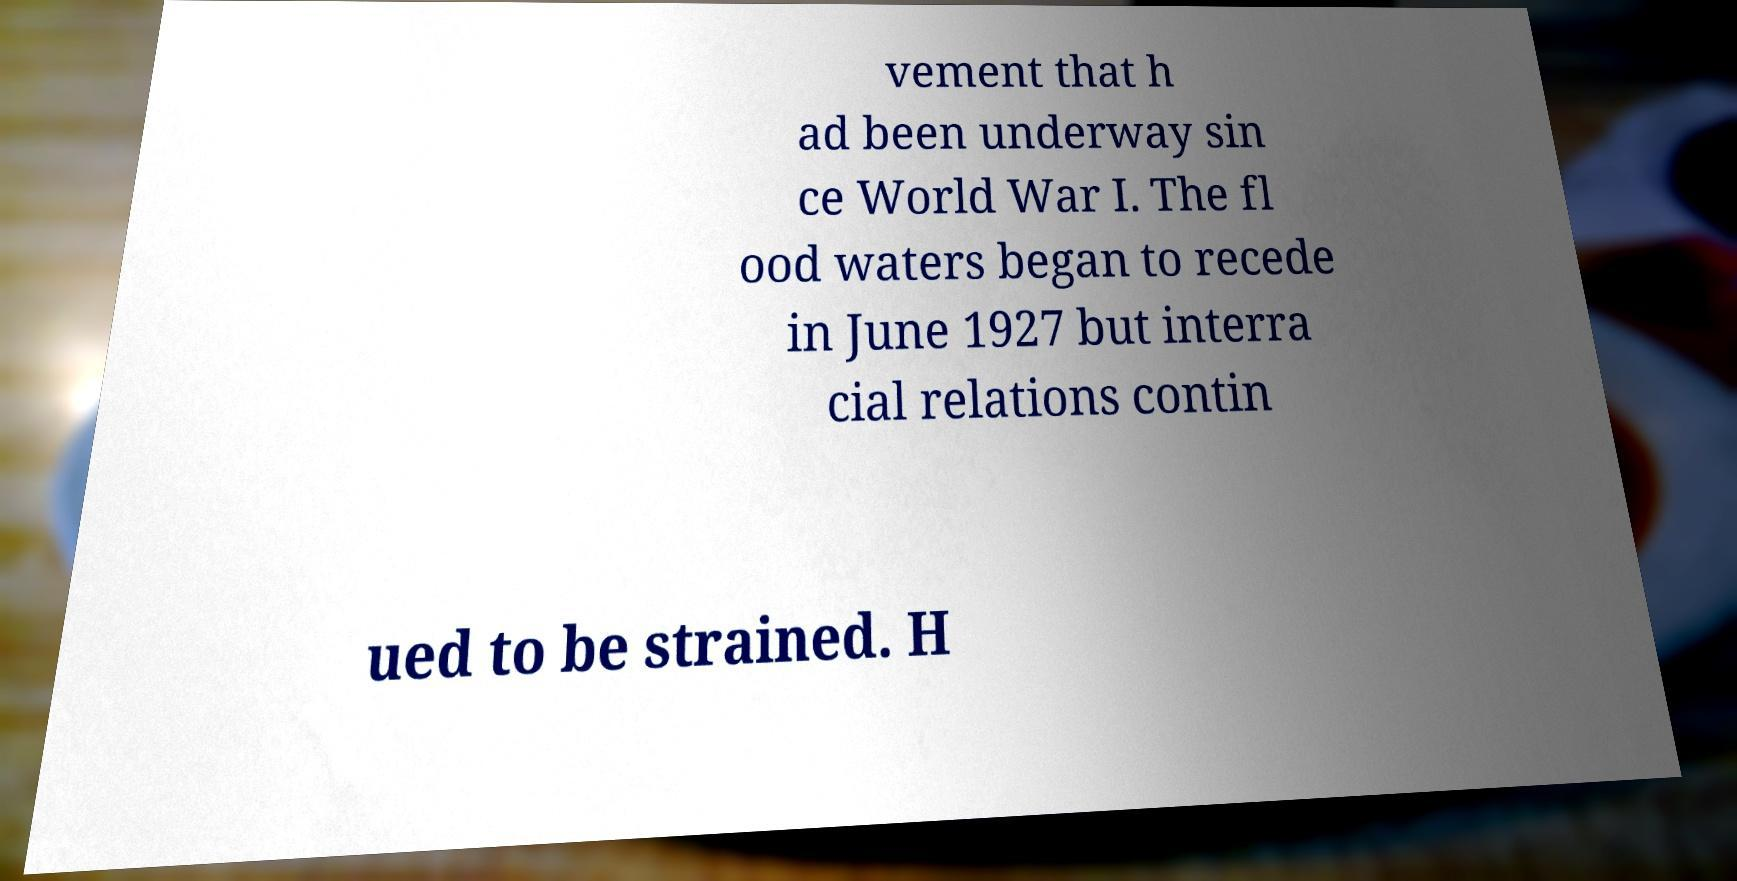Could you extract and type out the text from this image? vement that h ad been underway sin ce World War I. The fl ood waters began to recede in June 1927 but interra cial relations contin ued to be strained. H 